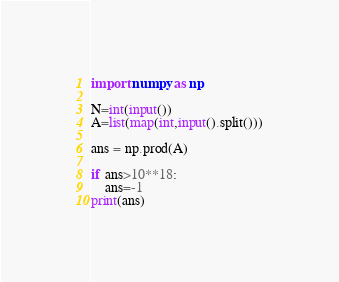Convert code to text. <code><loc_0><loc_0><loc_500><loc_500><_Python_>import numpy as np

N=int(input())
A=list(map(int,input().split()))

ans = np.prod(A)
    
if ans>10**18:
    ans=-1
print(ans)</code> 